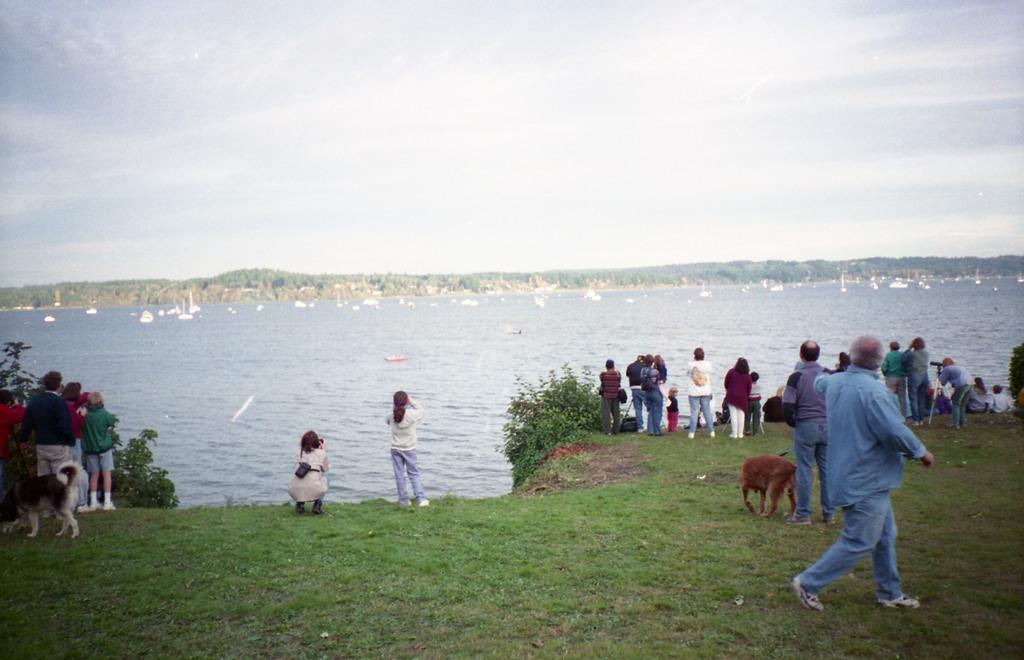In one or two sentences, can you explain what this image depicts? In the left bottom of the image, there are group of people standing in front of the lake. In the bottom, there is a grass visible and a dog visible. On the top, a sky visible of blue in color. And in the middle, a water is visible in which boats are there. This image is taken during day time. 